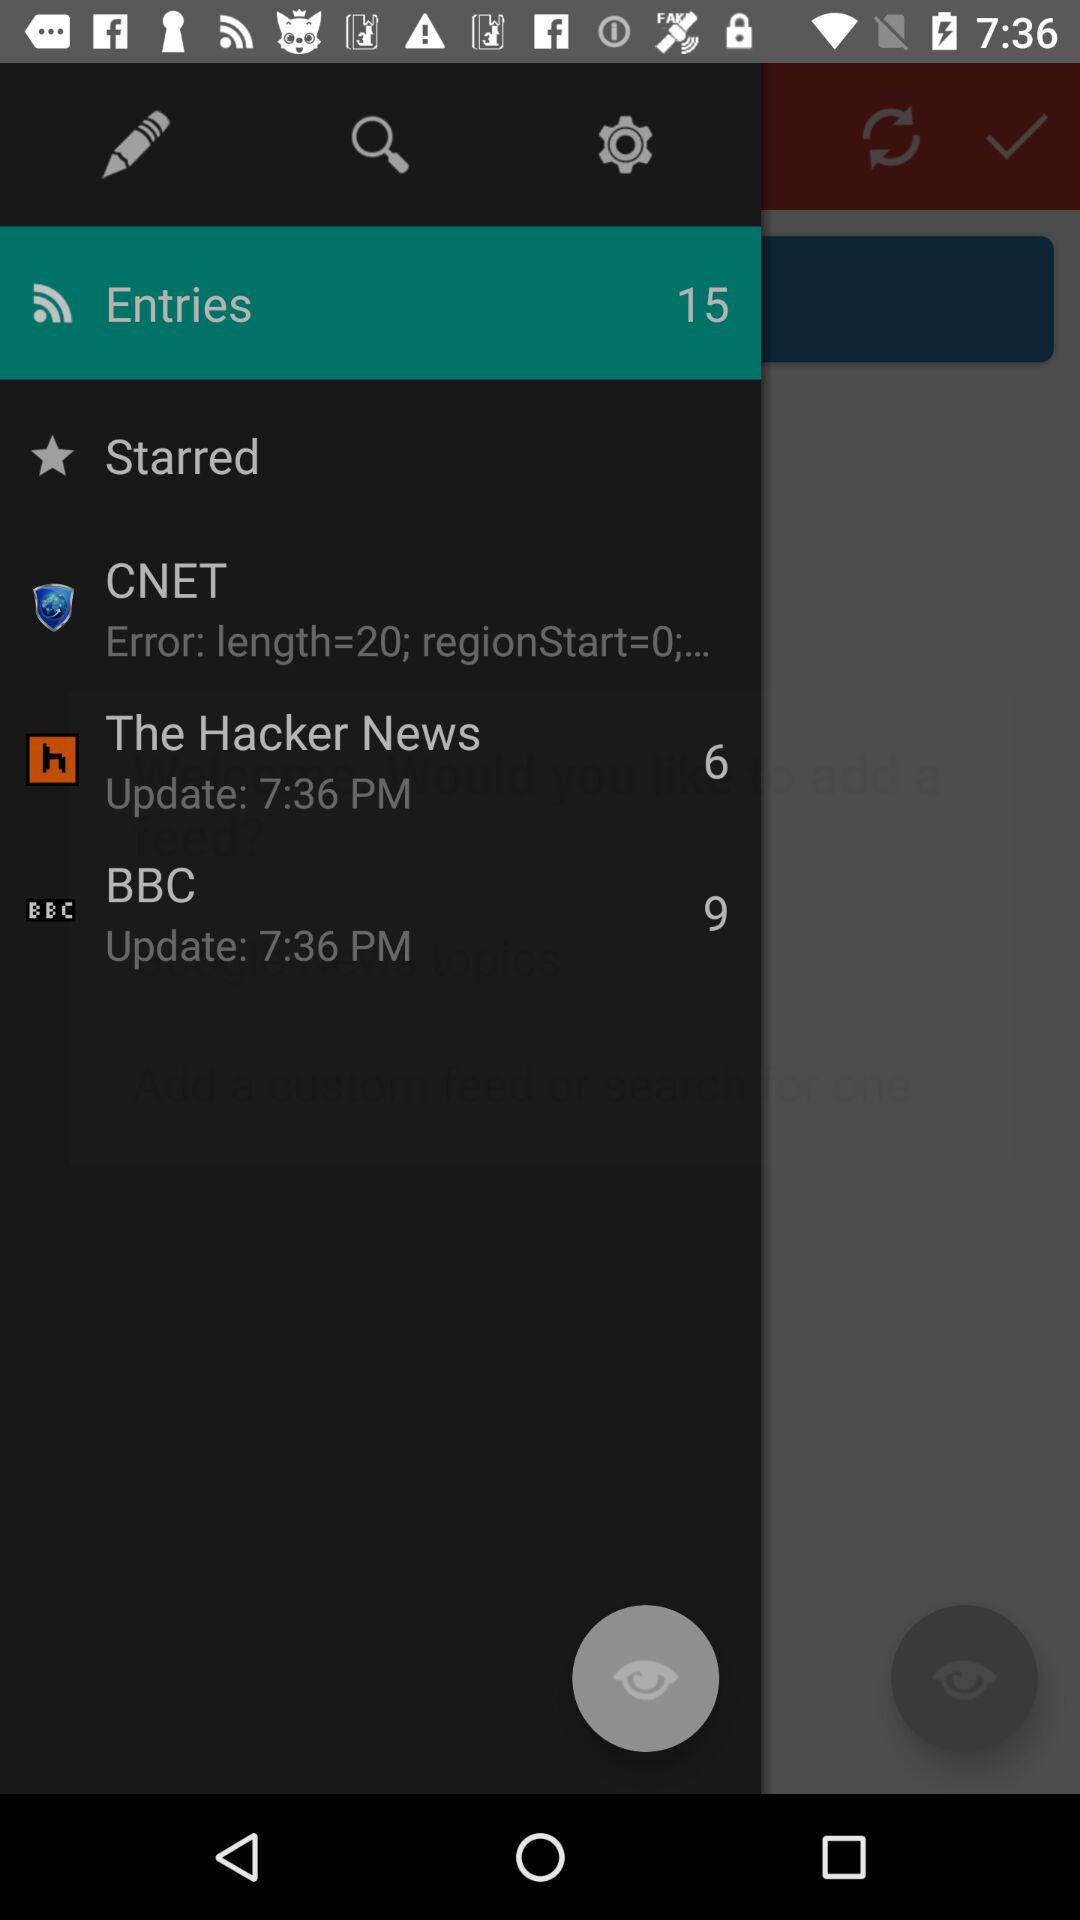What is the length? The length is 20. 